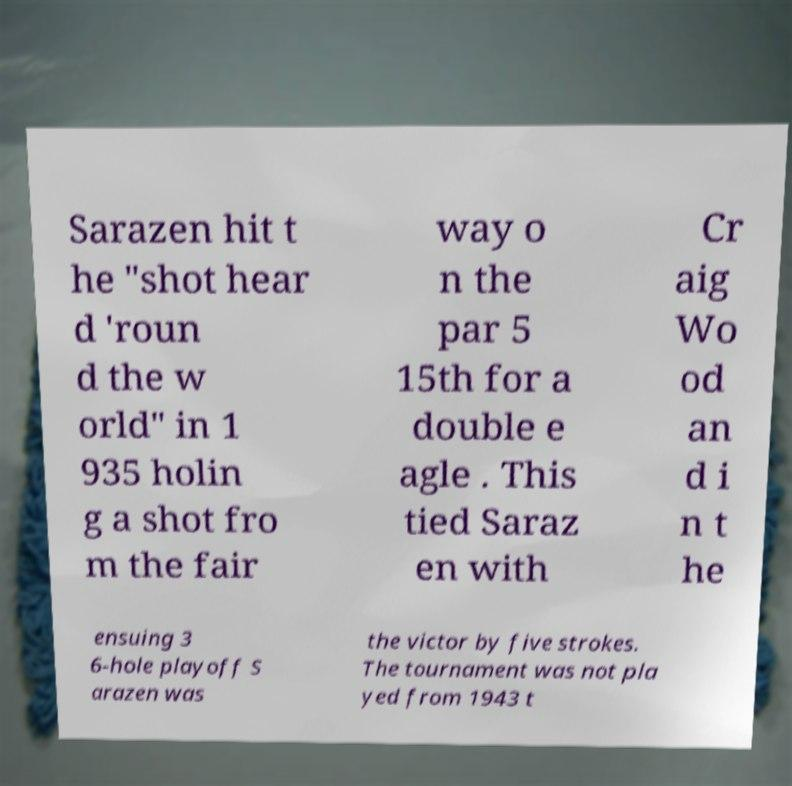Please identify and transcribe the text found in this image. Sarazen hit t he "shot hear d 'roun d the w orld" in 1 935 holin g a shot fro m the fair way o n the par 5 15th for a double e agle . This tied Saraz en with Cr aig Wo od an d i n t he ensuing 3 6-hole playoff S arazen was the victor by five strokes. The tournament was not pla yed from 1943 t 